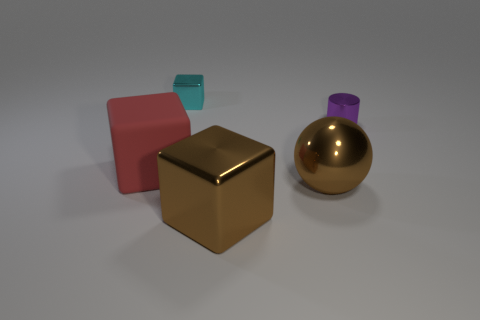There is a thing that is the same color as the shiny ball; what is its material?
Keep it short and to the point. Metal. Is there any other thing that has the same color as the big metallic cube?
Ensure brevity in your answer.  Yes. What size is the other block that is made of the same material as the cyan cube?
Offer a terse response. Large. There is a large red object; is it the same shape as the small object in front of the small cyan metallic thing?
Make the answer very short. No. The cyan metal thing is what size?
Offer a terse response. Small. Is the number of large red matte cubes that are to the right of the large brown shiny ball less than the number of cylinders?
Provide a succinct answer. Yes. How many red blocks are the same size as the red matte object?
Provide a short and direct response. 0. The thing that is the same color as the large metal sphere is what shape?
Give a very brief answer. Cube. There is a shiny cube that is in front of the small cyan metal cube; does it have the same color as the metal object that is to the left of the large brown metallic block?
Your answer should be very brief. No. There is a red thing; how many shiny cubes are in front of it?
Make the answer very short. 1. 